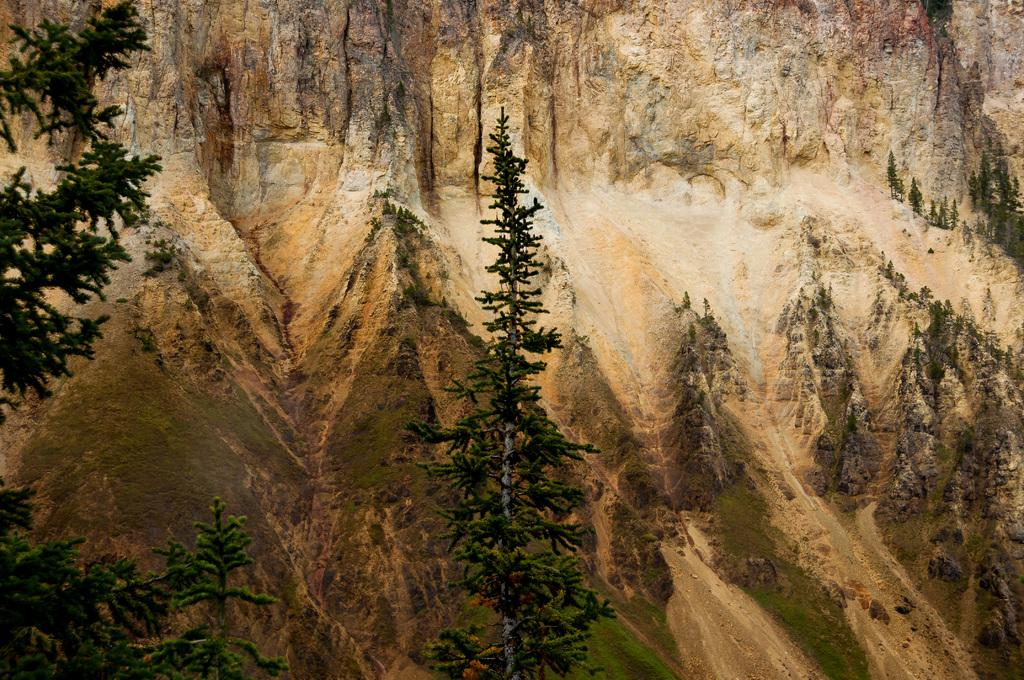What type of vegetation is present in the image? There are trees in the image. Can you describe any other objects or features in the background? There is a rock in the background of the image. What month is it in the image? The month cannot be determined from the image, as there is no information about the time of year or any seasonal indicators. 